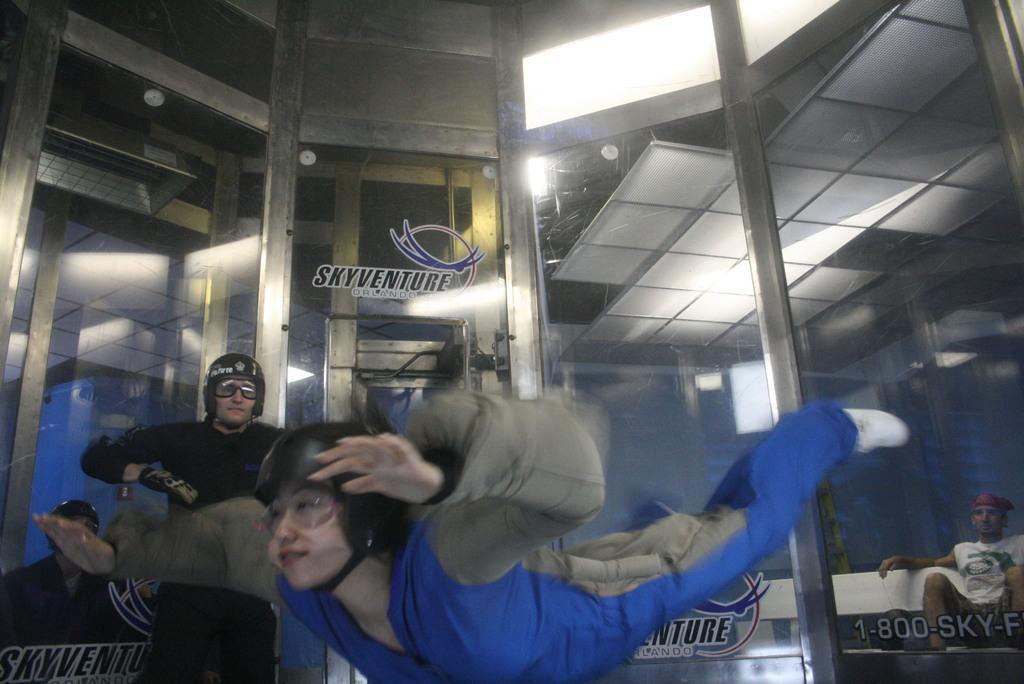Describe this image in one or two sentences. In this image, we can see people and are wearing coats and some are wearing helmets and one of them is wearing gloves and we can see some text and logos on the glass doors and there are lights. At the top, there is a roof. 